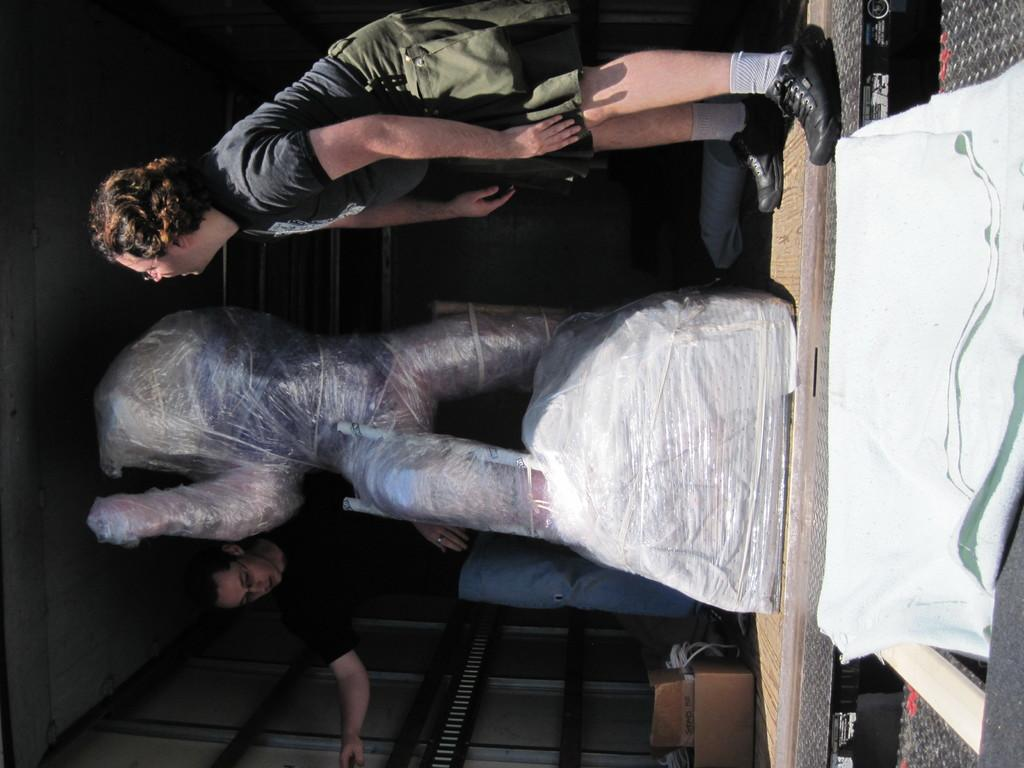How many people are in the image? There are two men in the image. What are the men doing in the image? The men are standing on the floor. Can you describe the object between the men? There is an object wrapped by a cover in between the men. What kind of respect does the minister show towards the coach in the image? There is no minister or coach present in the image, so it is not possible to determine any interaction between them. 